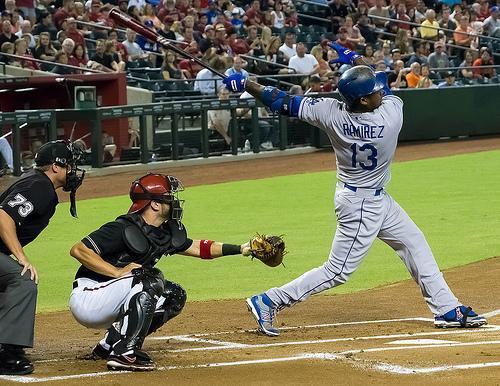How many players are pictured?
Give a very brief answer. 3. 